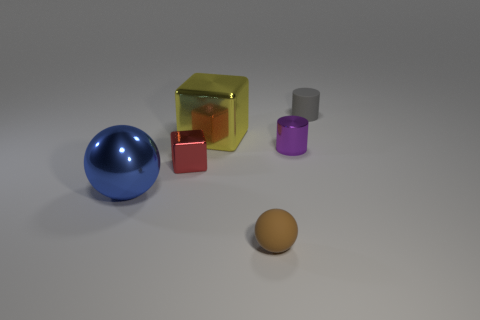Are there more brown things that are to the left of the metallic ball than cyan matte things?
Provide a succinct answer. No. There is a purple object that is made of the same material as the big yellow cube; what shape is it?
Your answer should be very brief. Cylinder. There is a large metal thing that is to the right of the ball that is behind the tiny ball; what is its color?
Your response must be concise. Yellow. Does the small red thing have the same shape as the small purple thing?
Your response must be concise. No. There is a red object that is the same shape as the yellow thing; what material is it?
Your response must be concise. Metal. There is a rubber thing that is behind the big shiny thing behind the large blue metal sphere; is there a small brown object on the left side of it?
Ensure brevity in your answer.  Yes. There is a big blue thing; does it have the same shape as the small rubber thing that is in front of the purple metal cylinder?
Ensure brevity in your answer.  Yes. Is there any other thing that is the same color as the tiny matte ball?
Your answer should be very brief. No. Are any cyan matte cylinders visible?
Make the answer very short. No. Is there a big yellow cube made of the same material as the red object?
Offer a very short reply. Yes. 